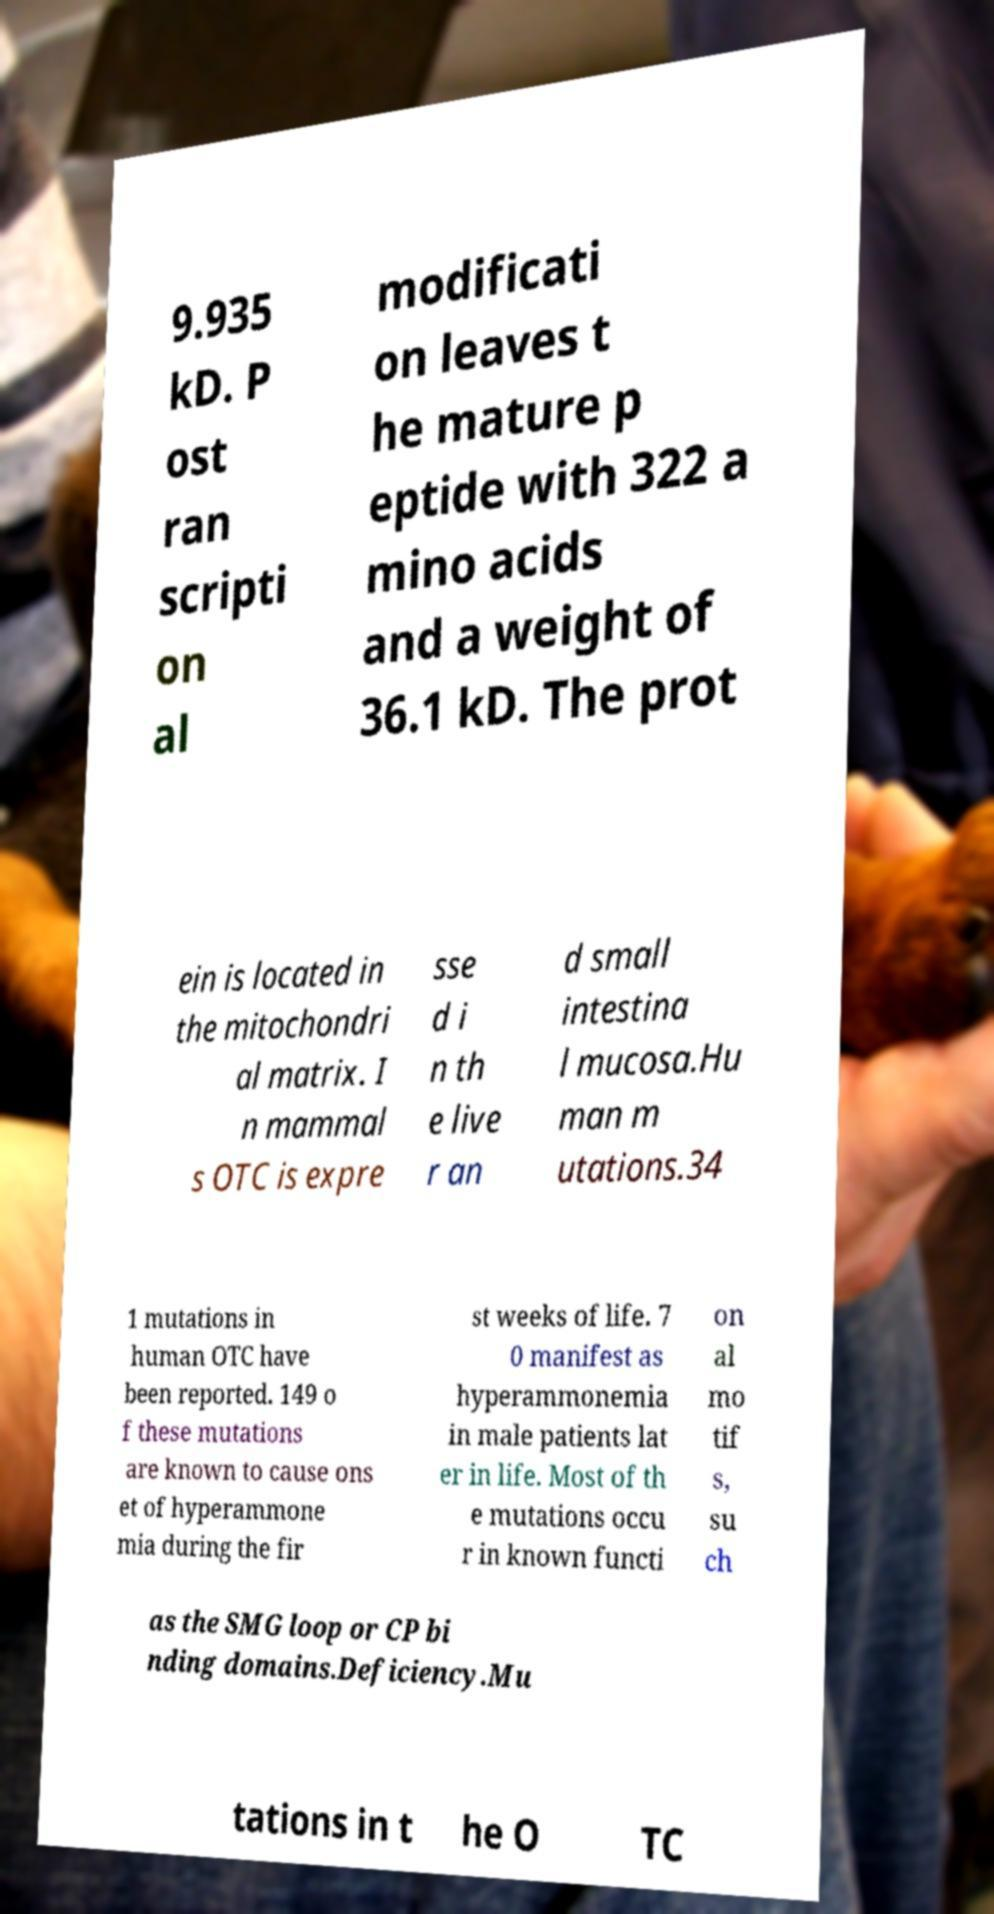There's text embedded in this image that I need extracted. Can you transcribe it verbatim? 9.935 kD. P ost ran scripti on al modificati on leaves t he mature p eptide with 322 a mino acids and a weight of 36.1 kD. The prot ein is located in the mitochondri al matrix. I n mammal s OTC is expre sse d i n th e live r an d small intestina l mucosa.Hu man m utations.34 1 mutations in human OTC have been reported. 149 o f these mutations are known to cause ons et of hyperammone mia during the fir st weeks of life. 7 0 manifest as hyperammonemia in male patients lat er in life. Most of th e mutations occu r in known functi on al mo tif s, su ch as the SMG loop or CP bi nding domains.Deficiency.Mu tations in t he O TC 